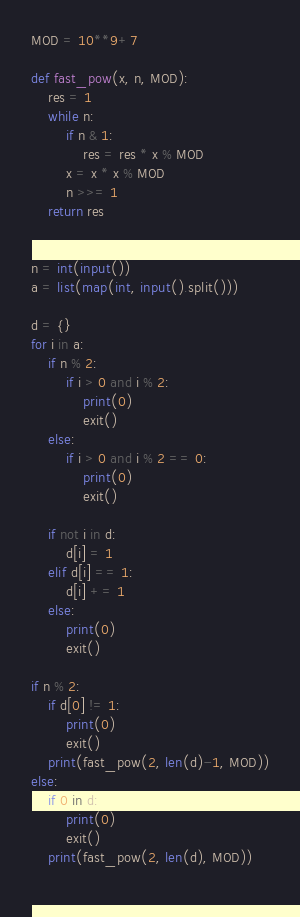<code> <loc_0><loc_0><loc_500><loc_500><_Python_>MOD = 10**9+7

def fast_pow(x, n, MOD):
    res = 1
    while n:
        if n & 1:
            res = res * x % MOD
        x = x * x % MOD
        n >>= 1
    return res


n = int(input())
a = list(map(int, input().split()))

d = {}
for i in a:
    if n % 2:
        if i > 0 and i % 2:
            print(0)
            exit()
    else:
        if i > 0 and i % 2 == 0:
            print(0)
            exit()

    if not i in d:
        d[i] = 1
    elif d[i] == 1:
        d[i] += 1
    else:
        print(0)
        exit()

if n % 2:
    if d[0] != 1:
        print(0)
        exit()
    print(fast_pow(2, len(d)-1, MOD))
else:
    if 0 in d:
        print(0)
        exit()
    print(fast_pow(2, len(d), MOD))
    </code> 